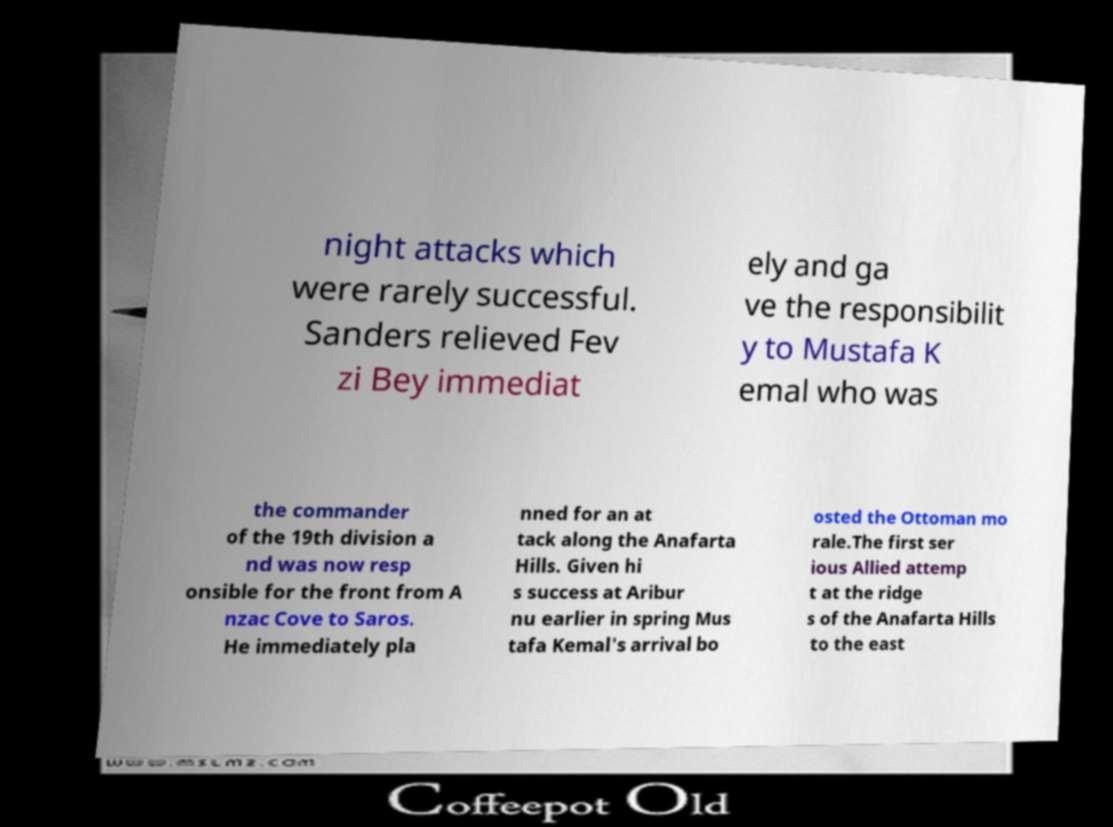Can you read and provide the text displayed in the image?This photo seems to have some interesting text. Can you extract and type it out for me? night attacks which were rarely successful. Sanders relieved Fev zi Bey immediat ely and ga ve the responsibilit y to Mustafa K emal who was the commander of the 19th division a nd was now resp onsible for the front from A nzac Cove to Saros. He immediately pla nned for an at tack along the Anafarta Hills. Given hi s success at Aribur nu earlier in spring Mus tafa Kemal's arrival bo osted the Ottoman mo rale.The first ser ious Allied attemp t at the ridge s of the Anafarta Hills to the east 